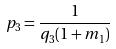<formula> <loc_0><loc_0><loc_500><loc_500>p _ { 3 } = \frac { 1 } { q _ { 3 } ( 1 + m _ { 1 } ) }</formula> 